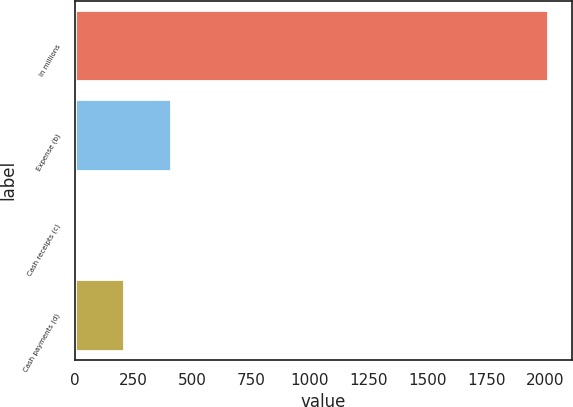Convert chart to OTSL. <chart><loc_0><loc_0><loc_500><loc_500><bar_chart><fcel>In millions<fcel>Expense (b)<fcel>Cash receipts (c)<fcel>Cash payments (d)<nl><fcel>2013<fcel>409<fcel>8<fcel>208.5<nl></chart> 